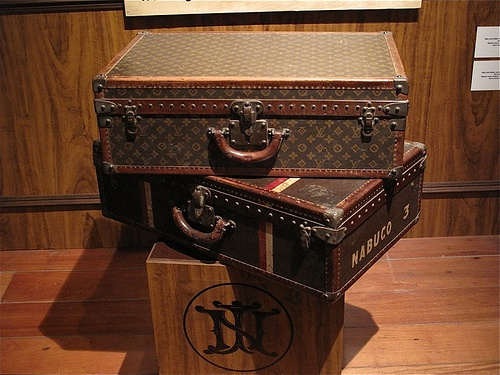Describe the objects in this image and their specific colors. I can see suitcase in black, maroon, and tan tones and suitcase in black, maroon, brown, and gray tones in this image. 